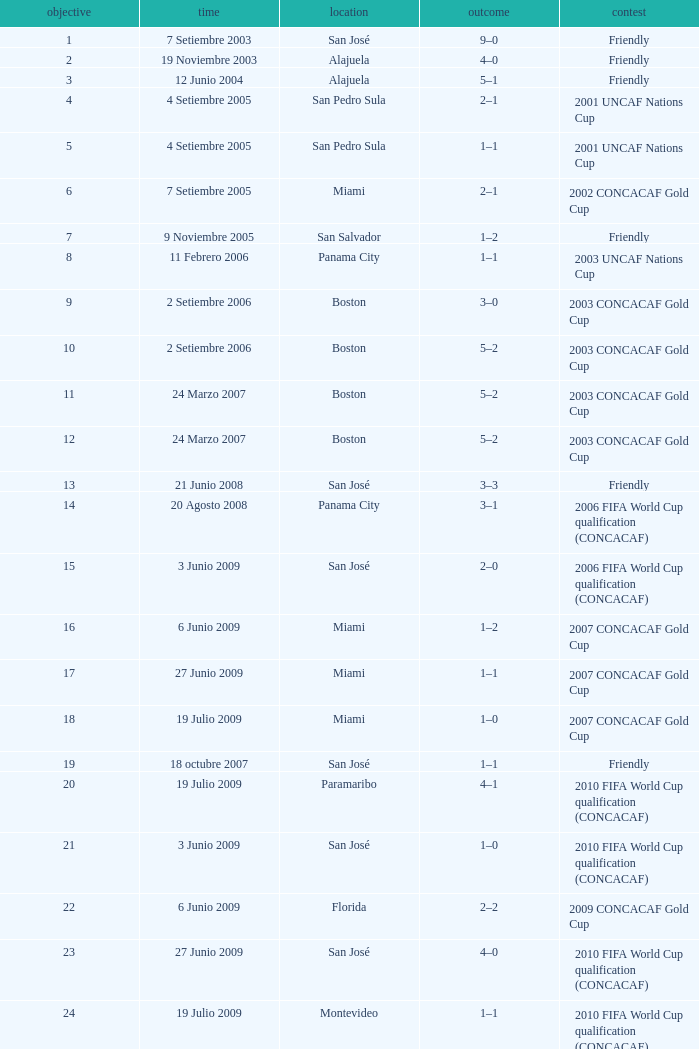How many goals were scored on 21 Junio 2008? 1.0. 